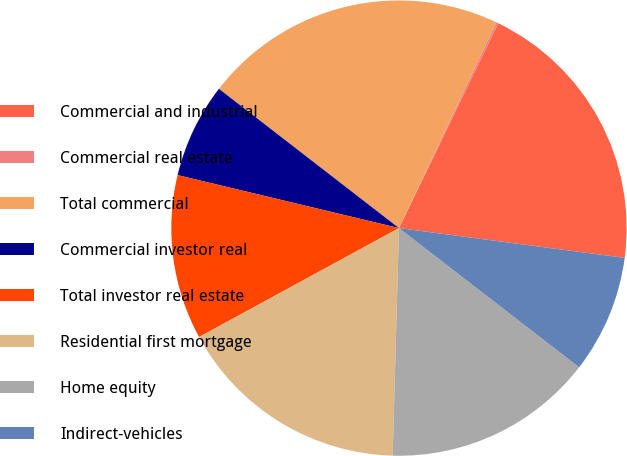<chart> <loc_0><loc_0><loc_500><loc_500><pie_chart><fcel>Commercial and industrial<fcel>Commercial real estate<fcel>Total commercial<fcel>Commercial investor real<fcel>Total investor real estate<fcel>Residential first mortgage<fcel>Home equity<fcel>Indirect-vehicles<nl><fcel>19.91%<fcel>0.15%<fcel>21.55%<fcel>6.74%<fcel>11.68%<fcel>16.62%<fcel>14.97%<fcel>8.38%<nl></chart> 